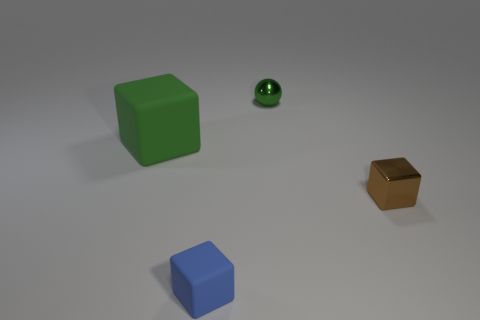Subtract all small blue cubes. How many cubes are left? 2 Subtract all blue blocks. How many blocks are left? 2 Add 2 large matte cubes. How many objects exist? 6 Subtract 1 balls. How many balls are left? 0 Subtract all balls. How many objects are left? 3 Add 4 green shiny objects. How many green shiny objects are left? 5 Add 1 balls. How many balls exist? 2 Subtract 0 gray cubes. How many objects are left? 4 Subtract all brown balls. Subtract all cyan blocks. How many balls are left? 1 Subtract all yellow cubes. How many purple spheres are left? 0 